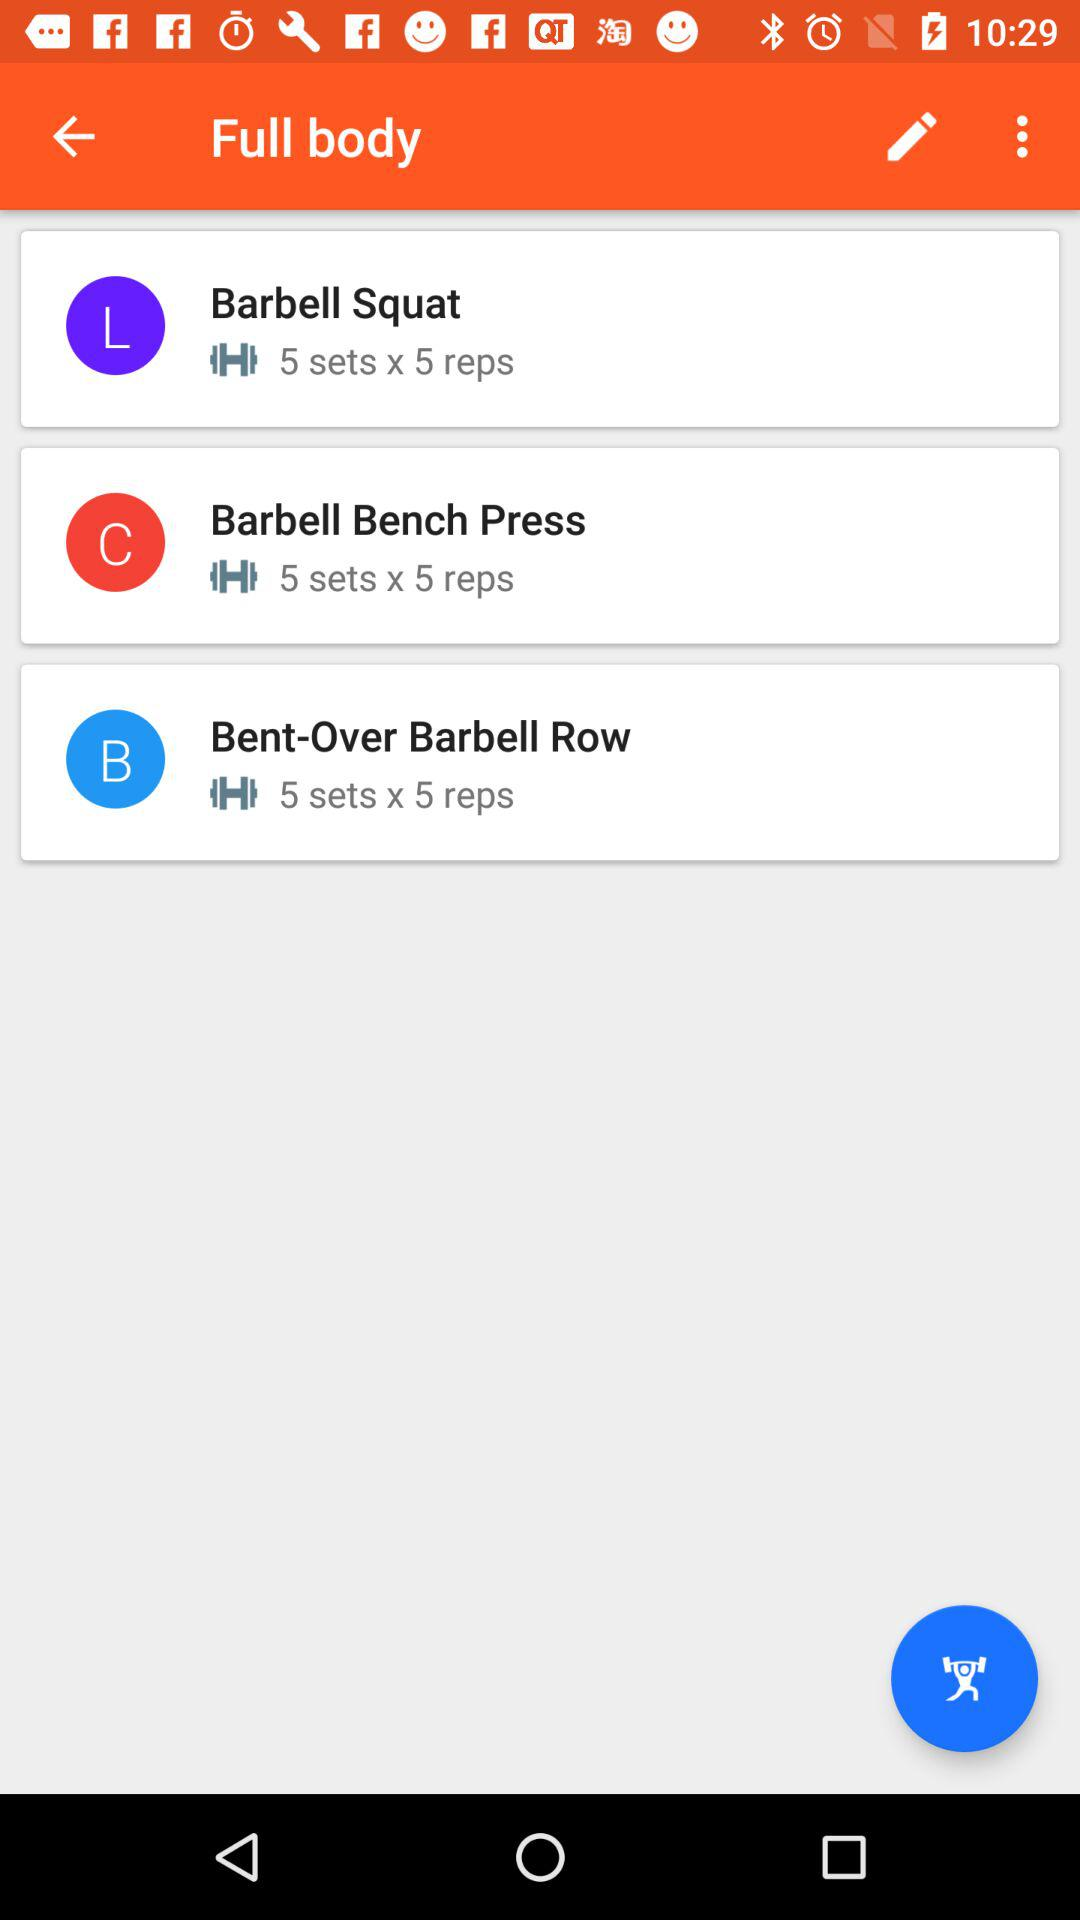How many exercises are there in the workout?
Answer the question using a single word or phrase. 3 